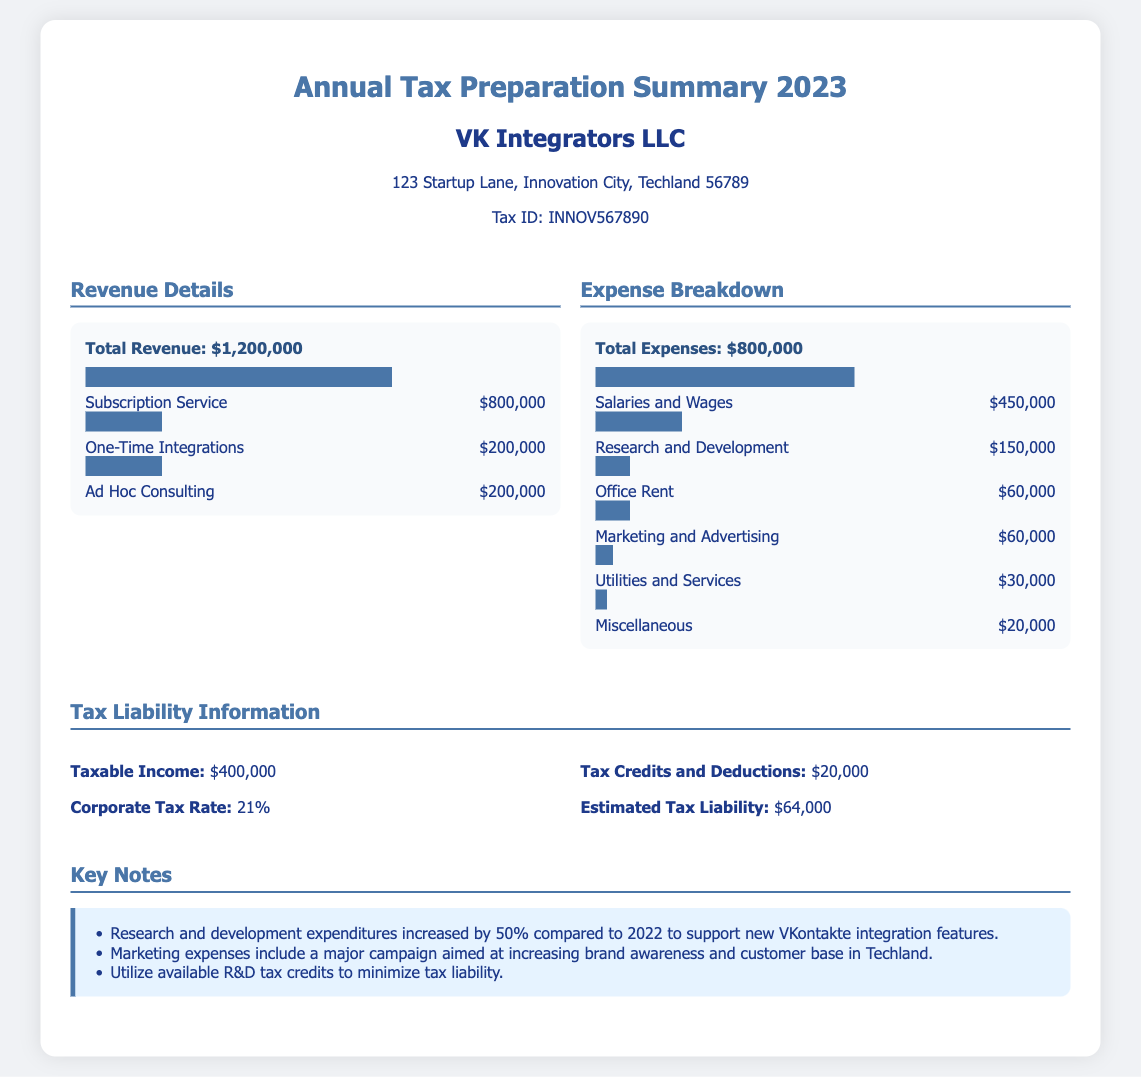what is the total revenue? The total revenue is stated as $1,200,000 in the document.
Answer: $1,200,000 what is the highest expense category? The highest expense category is Salaries and Wages at $450,000.
Answer: Salaries and Wages what is the corporate tax rate? The corporate tax rate specified in the document is 21%.
Answer: 21% what is the estimated tax liability? The estimated tax liability mentioned in the document is $64,000.
Answer: $64,000 how much was spent on Research and Development? The document states that $150,000 was spent on Research and Development.
Answer: $150,000 what is the taxable income? Taxable income is presented in the document as $400,000.
Answer: $400,000 how much are the tax credits and deductions? The tax credits and deductions amount to $20,000 according to the document.
Answer: $20,000 what percentage of total expenses is allocated to Marketing and Advertising? The document shows that $60,000 was spent on Marketing and Advertising, which is 7.5% of total expenses of $800,000.
Answer: 7.5% what increase was noted in R&D expenditures compared to 2022? The increase in research and development expenditures is noted as 50% compared to 2022.
Answer: 50% what was the primary focus of marketing expenses? The document states that marketing expenses aimed at increasing brand awareness and customer base in Techland.
Answer: increasing brand awareness and customer base in Techland 